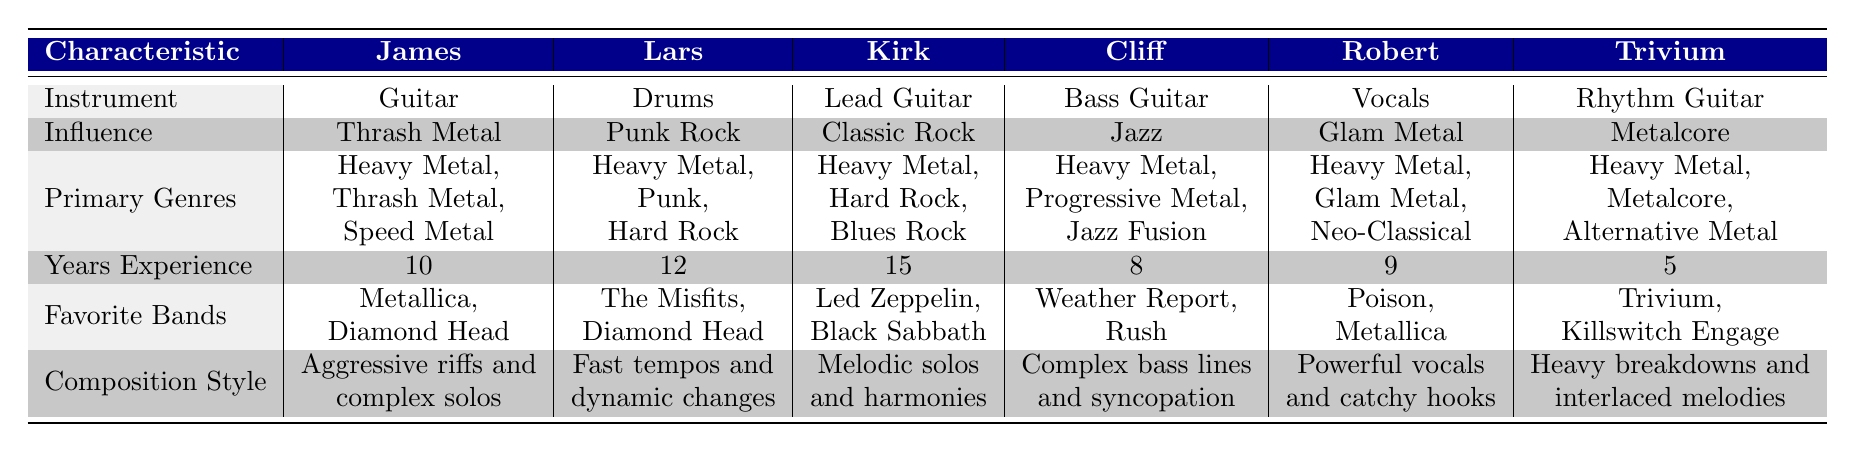What is the primary genre for James? The primary genres listed for James are Heavy Metal, Thrash Metal, and Speed Metal. According to the table, the question specifically asks for the primary genre, which based on his influence, would be Thrash Metal.
Answer: Thrash Metal Which band member has the most years of experience? Looking at the years of experience for each member: James has 10 years, Lars has 12, Kirk has 15, Cliff has 8, Robert has 9, and Trivium has 5 years. Therefore, the member with the most years of experience is Kirk with 15.
Answer: Kirk Is it true that Robert's influence is Glam Metal? The table states that Robert's influence is listed as Glam Metal. This directly answers the yes/no question about his influence.
Answer: Yes What is the composition style of Cliff? According to the table, Cliff's composition style is listed as "Complex bass lines and syncopation," which answers the question regarding his specific style.
Answer: Complex bass lines and syncopation Which member prefers heavier styles based on their primary genres? Evaluating the primary genres focusing on Heavy Metal, Thrash Metal, and Metalcore, James (Thrash Metal), Lars (Punk Rock), Kirk (Heavy Metal), Cliff (Progressive Metal and Jazz Fusion), Robert (Glam Metal), and Trivium (Metalcore) maintain a heavier style. James, Lars, Kirk, and Trivium prioritize heavier styles, with James and Trivium leaning toward the most aggressive forms. Specifically, James and Trivium emphasize heavy breakdowns, so the answer reflects that.
Answer: James and Trivium Calculate the average years of experience among all band members. To find the average, first sum the years of experience: 10 (James) + 12 (Lars) + 15 (Kirk) + 8 (Cliff) + 9 (Robert) + 5 (Trivium) = 59 years total. Next, divide by the number of members, 6, to find the average: 59 / 6 = approximately 9.83.
Answer: 9.83 Who favors Heavy Metal and also has a Classical influence in their favorites? Looking at the favorite bands of the members, the only band member whose favorite bands include a blend of Classic influences could be Kirk. He lists Led Zeppelin, a classic band, and influence in Heavy Metal. This leads to Kirk being the only member to match that criterion.
Answer: Kirk What are the favorite bands of Lars? The table indicates that Lars' favorite bands are The Misfits and Diamond Head. This directly answers the question about his preferences.
Answer: The Misfits, Diamond Head 